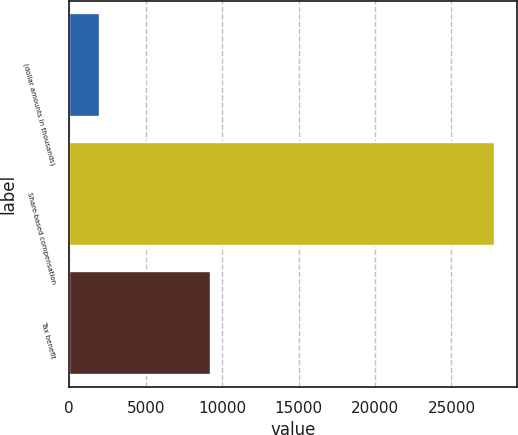Convert chart to OTSL. <chart><loc_0><loc_0><loc_500><loc_500><bar_chart><fcel>(dollar amounts in thousands)<fcel>Share-based compensation<fcel>Tax benefit<nl><fcel>2012<fcel>27873<fcel>9298<nl></chart> 